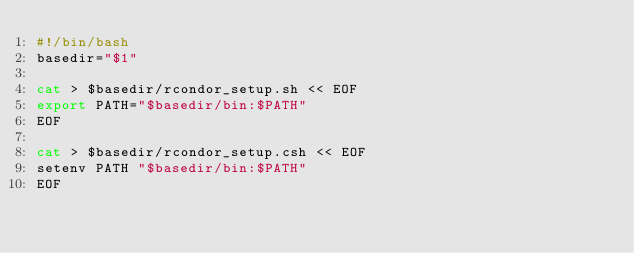<code> <loc_0><loc_0><loc_500><loc_500><_Bash_>#!/bin/bash
basedir="$1"

cat > $basedir/rcondor_setup.sh << EOF
export PATH="$basedir/bin:$PATH"
EOF

cat > $basedir/rcondor_setup.csh << EOF
setenv PATH "$basedir/bin:$PATH"
EOF

</code> 